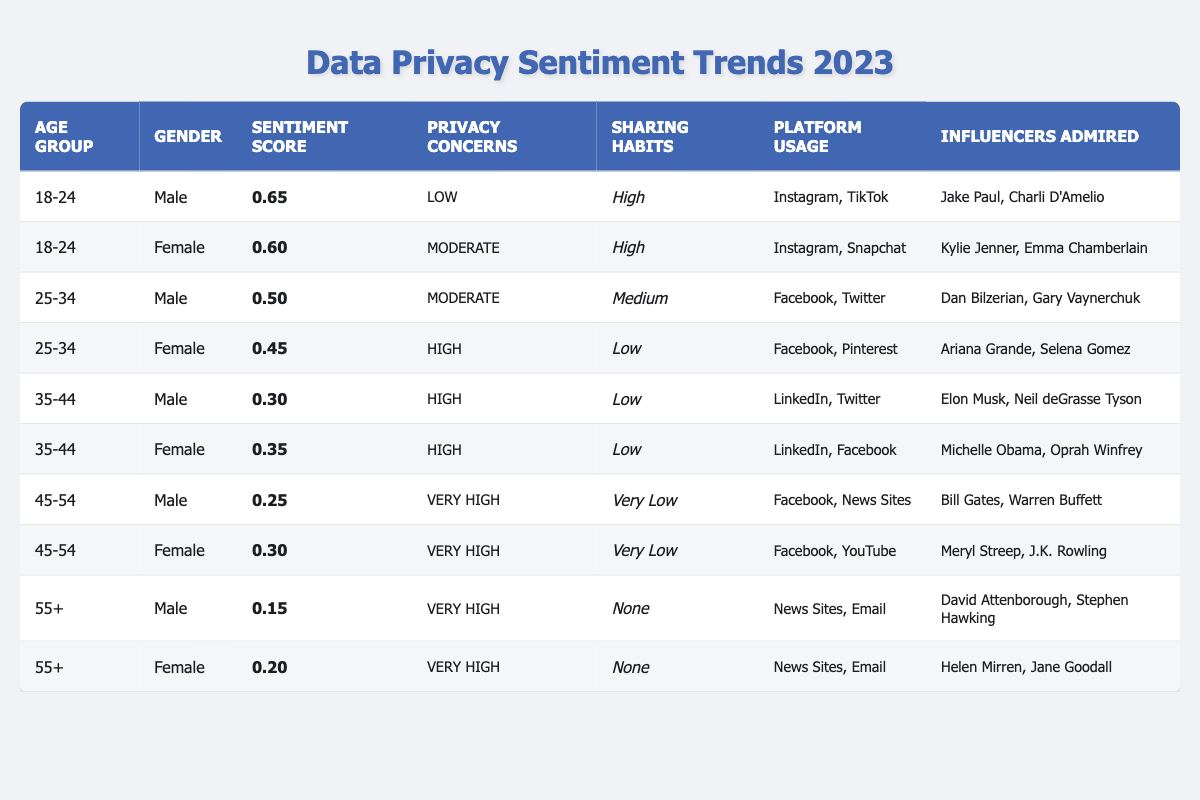What is the highest sentiment score and which age group does it belong to? The highest sentiment score in the table is 0.65, which is associated with the male demographic in the 18-24 age group.
Answer: 0.65, 18-24 male How many demographics have low privacy concerns? There are three demographics listed with low privacy concerns: 18-24 male, 18-24 female, and 25-34 male.
Answer: 3 What is the sentiment score for females in the 35-44 age group? The sentiment score for females in the 35-44 age group is 0.35, as shown in the table for that category.
Answer: 0.35 Which age group has the highest privacy concerns? The 45-54 and 55+ age groups both have very high privacy concerns according to the data provided.
Answer: 45-54, 55+ For which age groups do individuals have high sharing habits? The age groups 18-24 and 25-34 have individuals with high sharing habits. Specifically, both males and females in the 18-24 group and the male demographic in the 25-34 group.
Answer: 18-24, 25-34 What percentage of males aged 55 and older have "None" for sharing habits? The percentage for males aged 55 and older with "None" sharing habits is 100% since that is the only entry for this demographic in the data.
Answer: 100% Calculate the average sentiment score across all age groups. The sentiment scores are: 0.65 (18-24 male), 0.60 (18-24 female), 0.50 (25-34 male), 0.45 (25-34 female), 0.30 (35-44 male), 0.35 (35-44 female), 0.25 (45-54 male), 0.30 (45-54 female), 0.15 (55+ male), 0.20 (55+ female). The sum is 3.75, and there are 10 demographics, so the average is 3.75 / 10 = 0.375.
Answer: 0.375 Not counting the "None" category, which gender has the lowest average sentiment score? The average sentiment score for females (considering both 45-54 and 55+ age groups) is (0.30 + 0.20) / 2 = 0.25. Thus, females in these age categories have the lowest average sentiment score.
Answer: Female Are there any demographics that have very high privacy concerns with high sharing habits? No, all demographics that have very high privacy concerns also report very low or none sharing habits.
Answer: No What social media platforms are mostly used by males aged 25-34? Males aged 25-34 primarily use Facebook and Twitter, as indicated in the table.
Answer: Facebook, Twitter How many influencers are admired by females aged 45-54? Females aged 45-54 admire two influencers: Meryl Streep and J.K. Rowling.
Answer: 2 